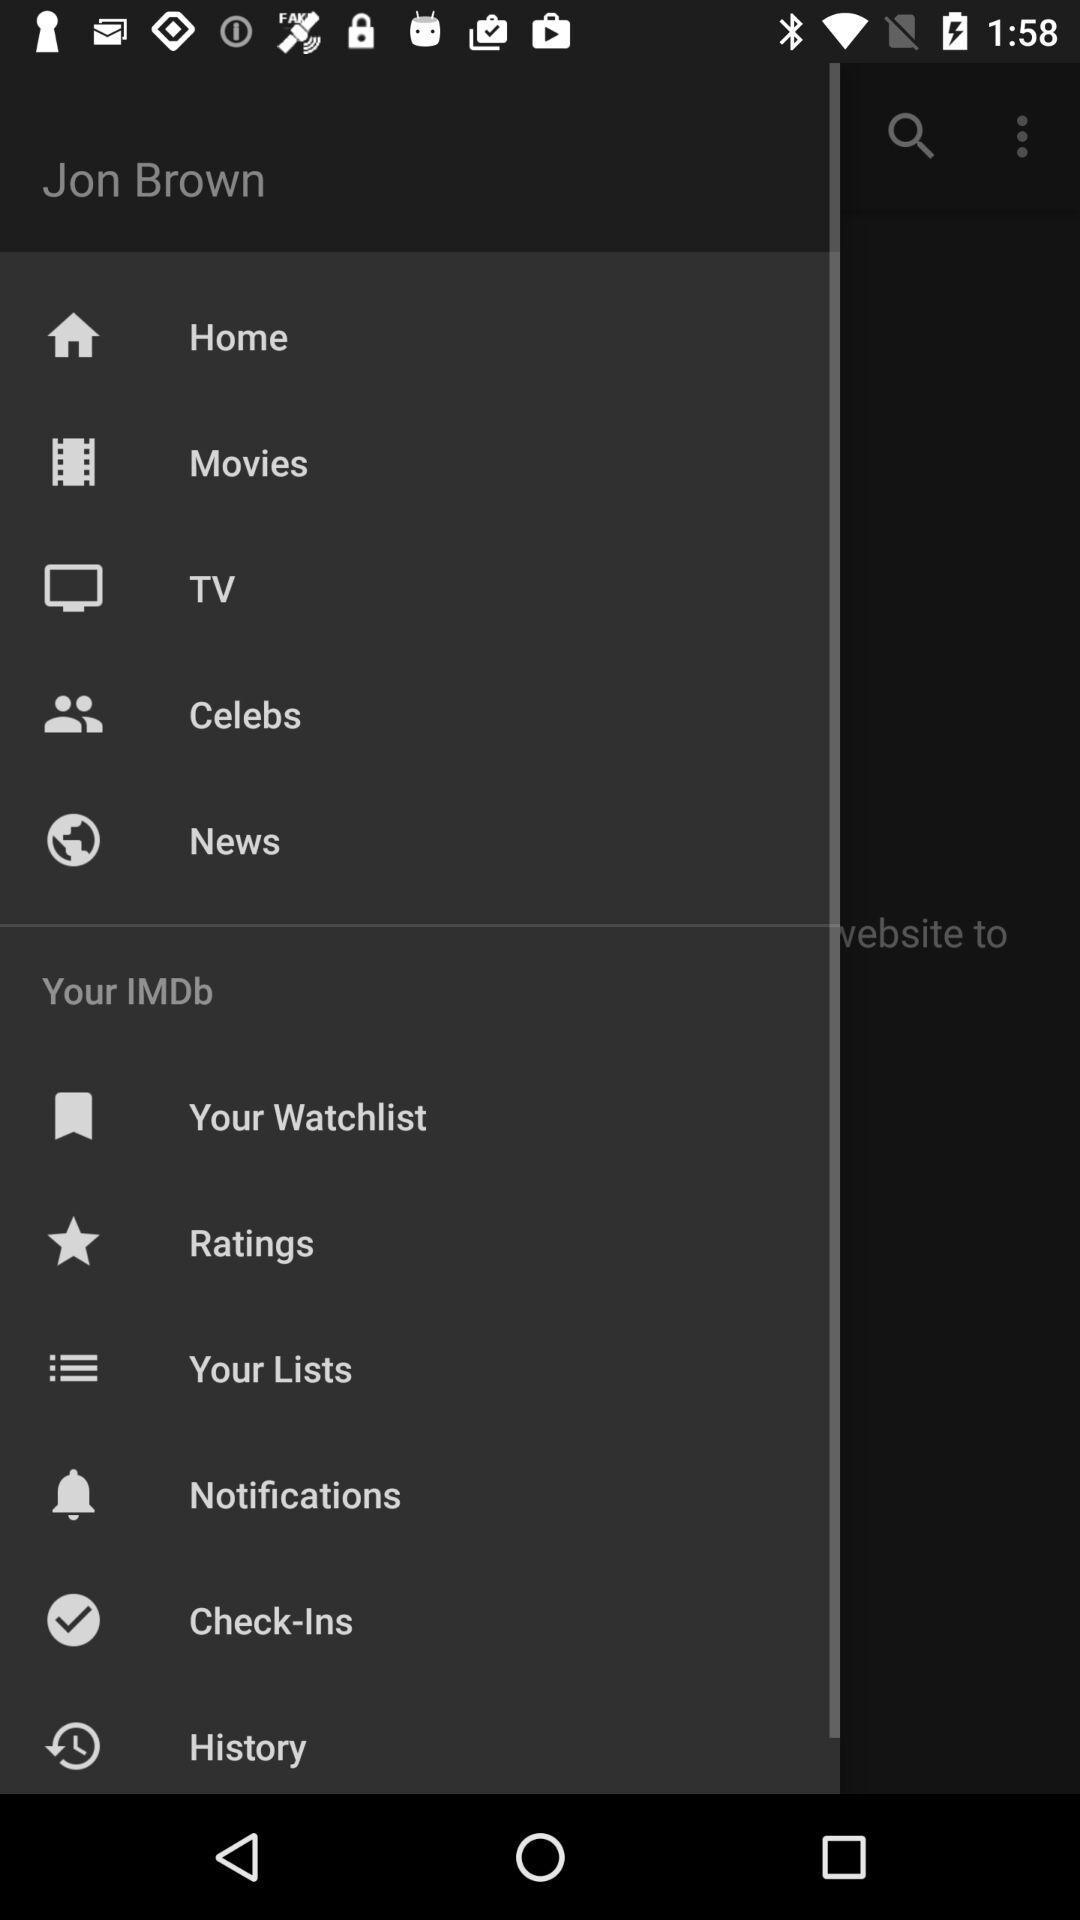What is the user name? The user name is Jon Brown. 